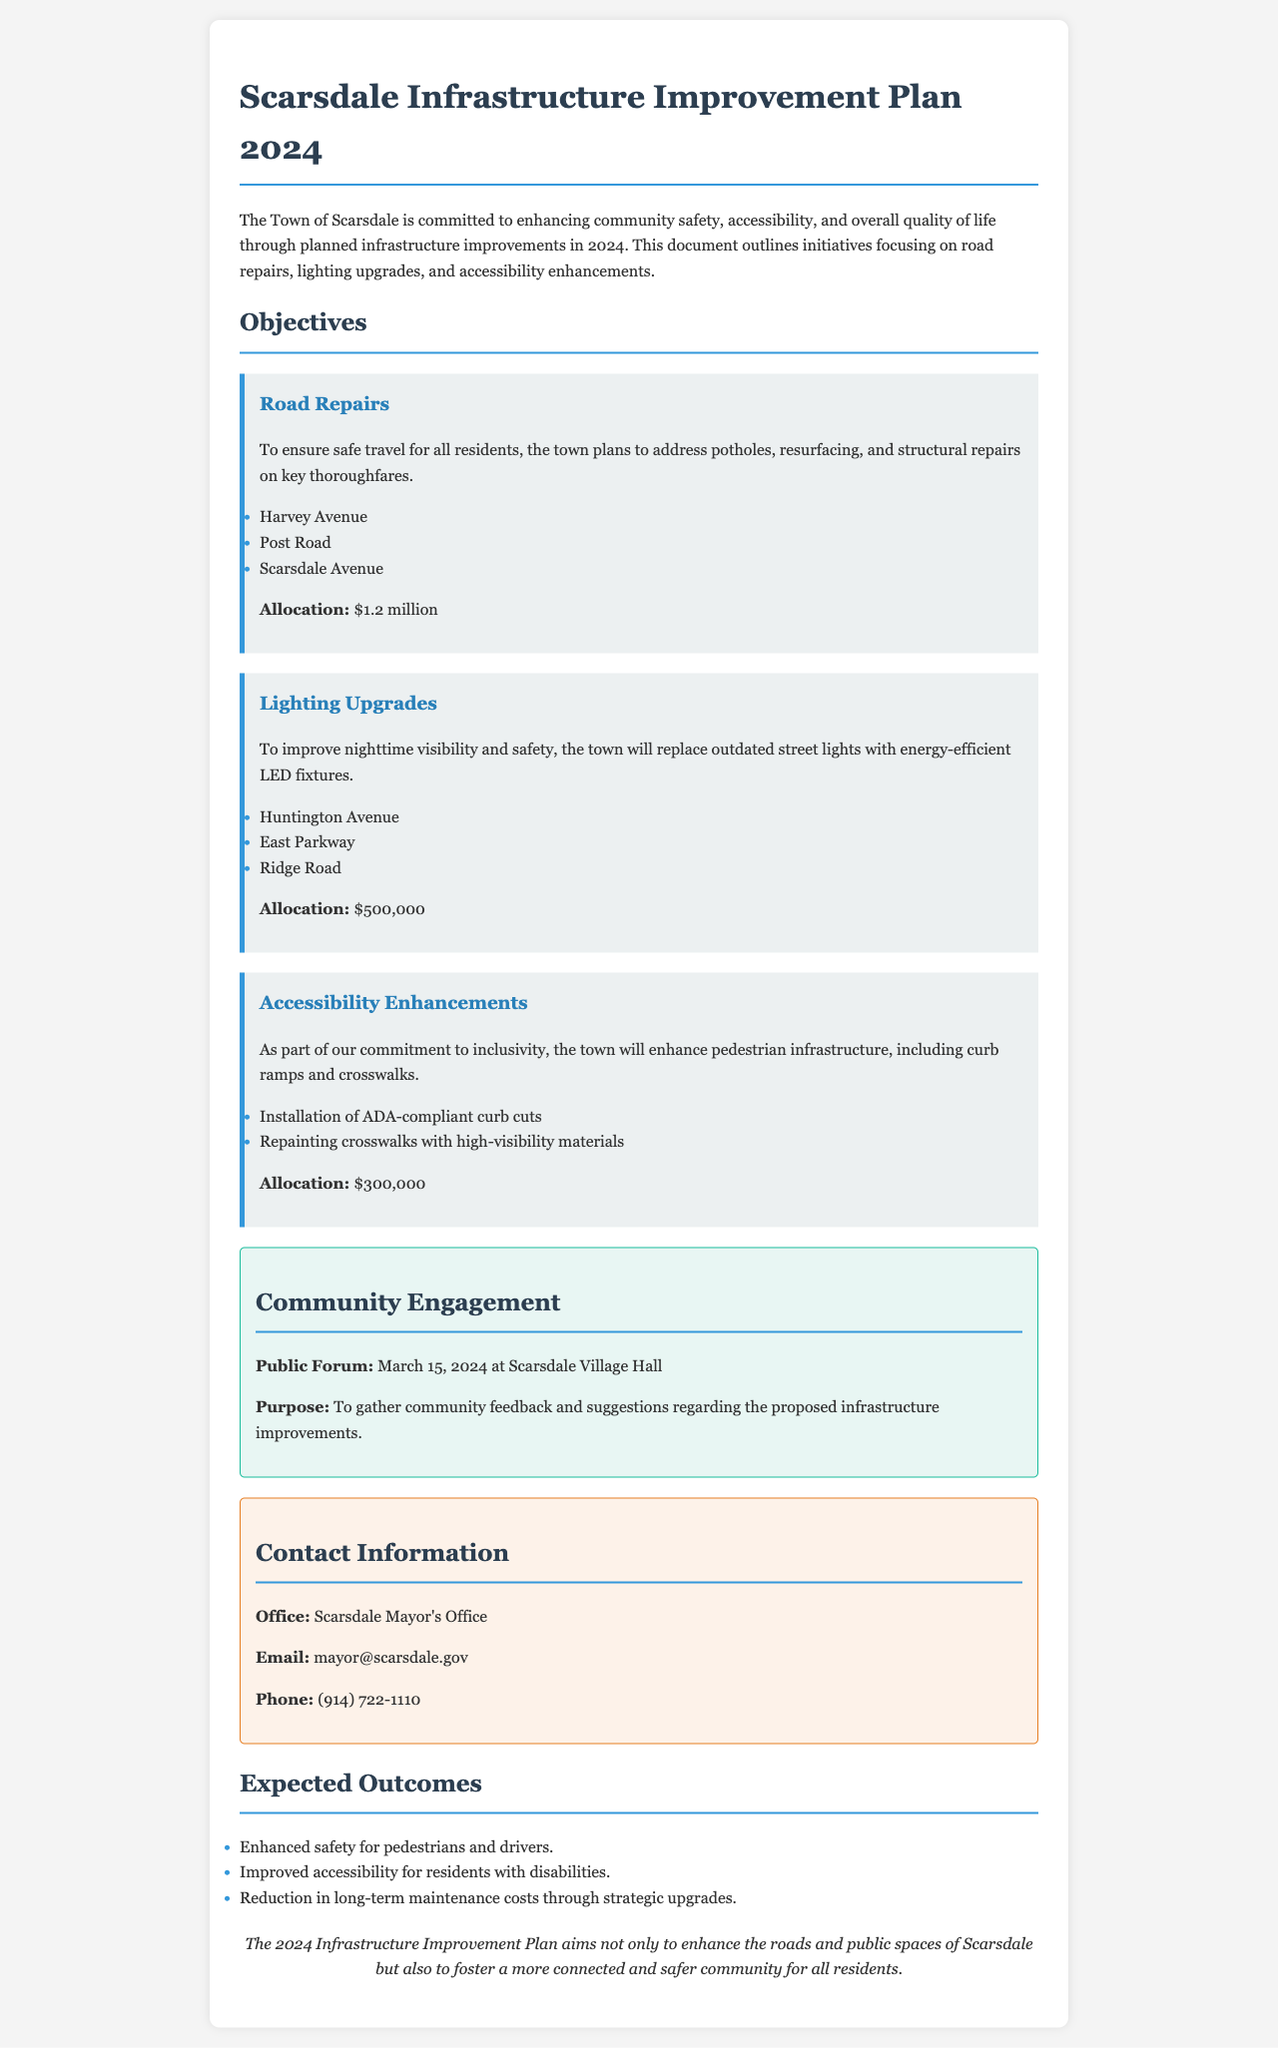What is the total allocation for road repairs? The total allocation for road repairs is mentioned in the document as $1.2 million.
Answer: $1.2 million What types of lighting will be replaced? The document specifies that outdated street lights will be replaced with energy-efficient LED fixtures.
Answer: LED fixtures When is the public forum scheduled? The scheduled date for the public forum is provided in the document as March 15, 2024.
Answer: March 15, 2024 Which streets are included in the lighting upgrades? The streets listed for lighting upgrades in the document are Huntington Avenue, East Parkway, and Ridge Road.
Answer: Huntington Avenue, East Parkway, Ridge Road What is the purpose of the community engagement section? The purpose of the community engagement section is to gather community feedback and suggestions regarding the proposed infrastructure improvements.
Answer: Gather community feedback How many key areas are outlined in the infrastructure plan? The document highlights three key areas: road repairs, lighting upgrades, and accessibility enhancements.
Answer: Three What is the expected outcome related to accessibility? One expected outcome mentioned in the document is improved accessibility for residents with disabilities.
Answer: Improved accessibility Which office can residents contact for more information? The office residents can contact for more information is the Scarsdale Mayor's Office.
Answer: Scarsdale Mayor's Office What enhancements will be made for accessibility? The document mentions installation of ADA-compliant curb cuts and repainting crosswalks with high-visibility materials as enhancements.
Answer: ADA-compliant curb cuts and high-visibility crosswalks 